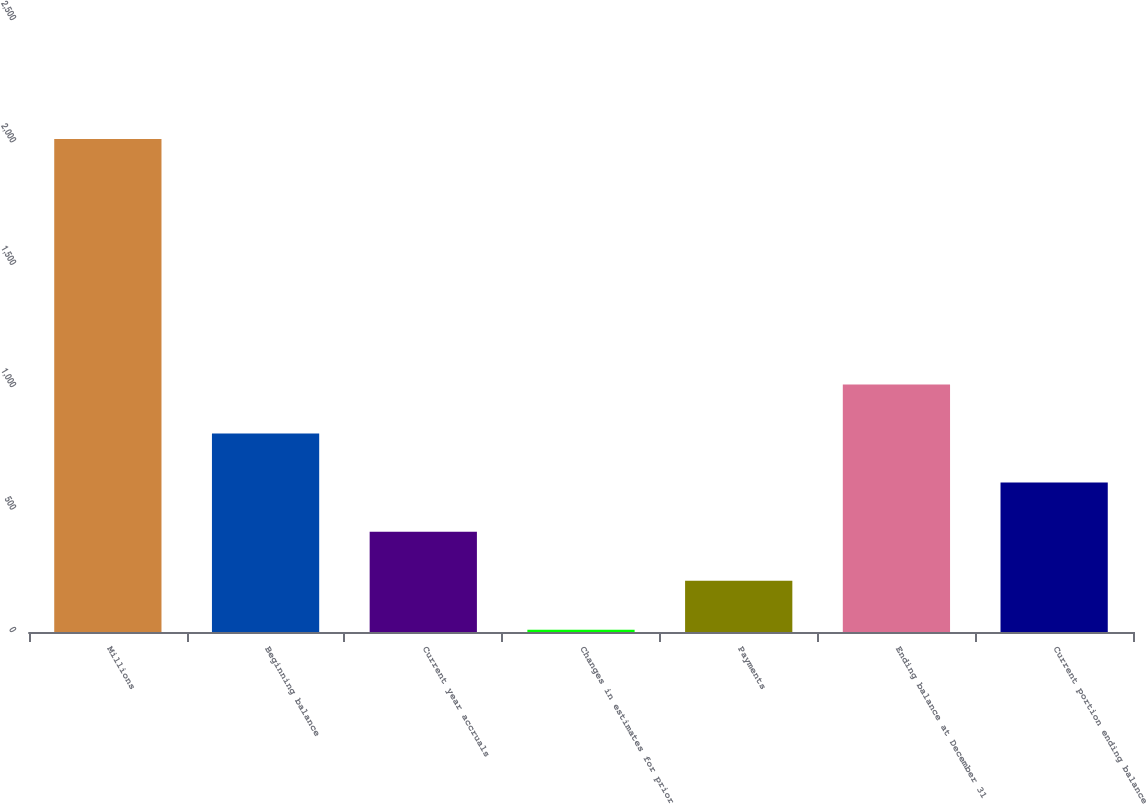<chart> <loc_0><loc_0><loc_500><loc_500><bar_chart><fcel>Millions<fcel>Beginning balance<fcel>Current year accruals<fcel>Changes in estimates for prior<fcel>Payments<fcel>Ending balance at December 31<fcel>Current portion ending balance<nl><fcel>2014<fcel>811<fcel>410<fcel>9<fcel>209.5<fcel>1011.5<fcel>610.5<nl></chart> 